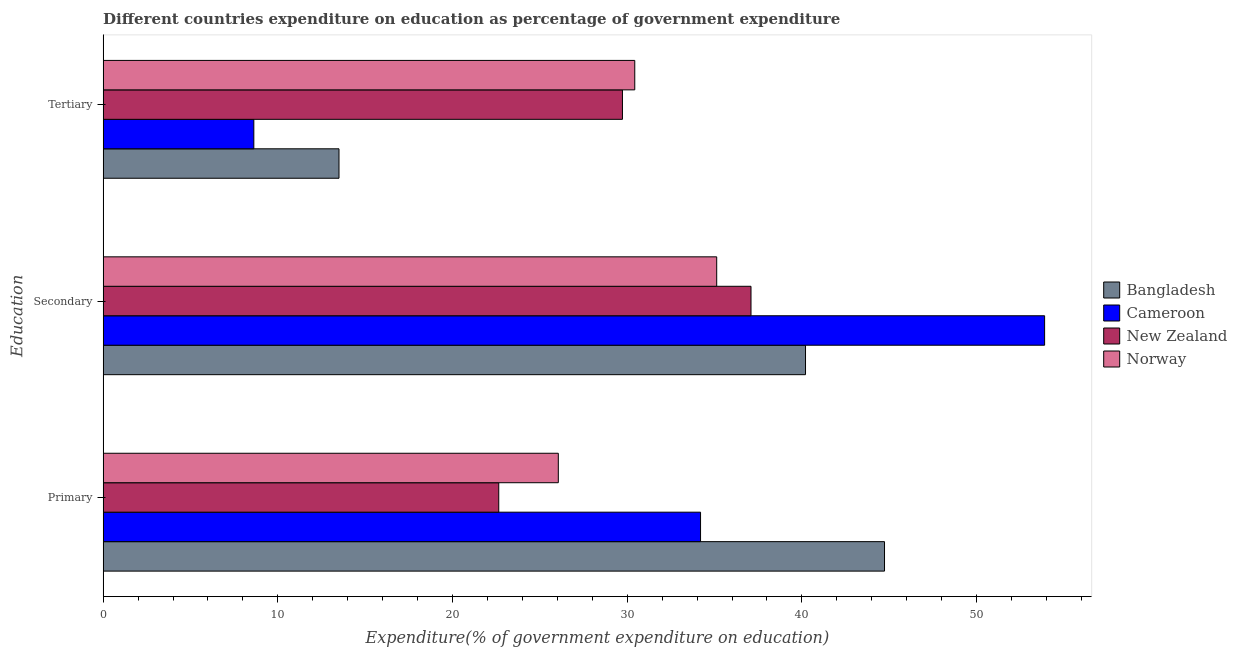How many different coloured bars are there?
Offer a very short reply. 4. How many groups of bars are there?
Your response must be concise. 3. Are the number of bars per tick equal to the number of legend labels?
Make the answer very short. Yes. Are the number of bars on each tick of the Y-axis equal?
Your answer should be compact. Yes. What is the label of the 1st group of bars from the top?
Keep it short and to the point. Tertiary. What is the expenditure on primary education in Norway?
Provide a succinct answer. 26.06. Across all countries, what is the maximum expenditure on tertiary education?
Your response must be concise. 30.43. Across all countries, what is the minimum expenditure on secondary education?
Offer a very short reply. 35.12. In which country was the expenditure on tertiary education maximum?
Keep it short and to the point. Norway. In which country was the expenditure on tertiary education minimum?
Keep it short and to the point. Cameroon. What is the total expenditure on secondary education in the graph?
Give a very brief answer. 166.31. What is the difference between the expenditure on secondary education in Norway and that in Bangladesh?
Provide a short and direct response. -5.08. What is the difference between the expenditure on primary education in New Zealand and the expenditure on tertiary education in Cameroon?
Offer a terse response. 14.02. What is the average expenditure on primary education per country?
Your response must be concise. 31.91. What is the difference between the expenditure on secondary education and expenditure on primary education in New Zealand?
Offer a terse response. 14.44. In how many countries, is the expenditure on secondary education greater than 22 %?
Provide a succinct answer. 4. What is the ratio of the expenditure on primary education in Norway to that in Cameroon?
Provide a succinct answer. 0.76. What is the difference between the highest and the second highest expenditure on tertiary education?
Give a very brief answer. 0.7. What is the difference between the highest and the lowest expenditure on primary education?
Offer a terse response. 22.08. What does the 3rd bar from the top in Primary represents?
Give a very brief answer. Cameroon. Is it the case that in every country, the sum of the expenditure on primary education and expenditure on secondary education is greater than the expenditure on tertiary education?
Offer a terse response. Yes. How many countries are there in the graph?
Keep it short and to the point. 4. Does the graph contain any zero values?
Offer a very short reply. No. Does the graph contain grids?
Your answer should be very brief. No. How many legend labels are there?
Offer a terse response. 4. How are the legend labels stacked?
Provide a succinct answer. Vertical. What is the title of the graph?
Keep it short and to the point. Different countries expenditure on education as percentage of government expenditure. Does "Swaziland" appear as one of the legend labels in the graph?
Your answer should be very brief. No. What is the label or title of the X-axis?
Make the answer very short. Expenditure(% of government expenditure on education). What is the label or title of the Y-axis?
Provide a short and direct response. Education. What is the Expenditure(% of government expenditure on education) of Bangladesh in Primary?
Ensure brevity in your answer.  44.73. What is the Expenditure(% of government expenditure on education) of Cameroon in Primary?
Give a very brief answer. 34.2. What is the Expenditure(% of government expenditure on education) of New Zealand in Primary?
Ensure brevity in your answer.  22.65. What is the Expenditure(% of government expenditure on education) of Norway in Primary?
Offer a terse response. 26.06. What is the Expenditure(% of government expenditure on education) in Bangladesh in Secondary?
Make the answer very short. 40.21. What is the Expenditure(% of government expenditure on education) of Cameroon in Secondary?
Make the answer very short. 53.89. What is the Expenditure(% of government expenditure on education) in New Zealand in Secondary?
Provide a short and direct response. 37.09. What is the Expenditure(% of government expenditure on education) in Norway in Secondary?
Your answer should be very brief. 35.12. What is the Expenditure(% of government expenditure on education) in Bangladesh in Tertiary?
Offer a very short reply. 13.5. What is the Expenditure(% of government expenditure on education) of Cameroon in Tertiary?
Keep it short and to the point. 8.63. What is the Expenditure(% of government expenditure on education) of New Zealand in Tertiary?
Make the answer very short. 29.73. What is the Expenditure(% of government expenditure on education) in Norway in Tertiary?
Provide a short and direct response. 30.43. Across all Education, what is the maximum Expenditure(% of government expenditure on education) in Bangladesh?
Keep it short and to the point. 44.73. Across all Education, what is the maximum Expenditure(% of government expenditure on education) of Cameroon?
Your answer should be very brief. 53.89. Across all Education, what is the maximum Expenditure(% of government expenditure on education) of New Zealand?
Your answer should be very brief. 37.09. Across all Education, what is the maximum Expenditure(% of government expenditure on education) of Norway?
Your answer should be very brief. 35.12. Across all Education, what is the minimum Expenditure(% of government expenditure on education) of Bangladesh?
Provide a succinct answer. 13.5. Across all Education, what is the minimum Expenditure(% of government expenditure on education) of Cameroon?
Provide a succinct answer. 8.63. Across all Education, what is the minimum Expenditure(% of government expenditure on education) of New Zealand?
Offer a very short reply. 22.65. Across all Education, what is the minimum Expenditure(% of government expenditure on education) of Norway?
Provide a succinct answer. 26.06. What is the total Expenditure(% of government expenditure on education) in Bangladesh in the graph?
Ensure brevity in your answer.  98.44. What is the total Expenditure(% of government expenditure on education) of Cameroon in the graph?
Ensure brevity in your answer.  96.71. What is the total Expenditure(% of government expenditure on education) of New Zealand in the graph?
Your answer should be compact. 89.46. What is the total Expenditure(% of government expenditure on education) in Norway in the graph?
Make the answer very short. 91.61. What is the difference between the Expenditure(% of government expenditure on education) in Bangladesh in Primary and that in Secondary?
Keep it short and to the point. 4.52. What is the difference between the Expenditure(% of government expenditure on education) of Cameroon in Primary and that in Secondary?
Offer a very short reply. -19.7. What is the difference between the Expenditure(% of government expenditure on education) in New Zealand in Primary and that in Secondary?
Your answer should be compact. -14.44. What is the difference between the Expenditure(% of government expenditure on education) of Norway in Primary and that in Secondary?
Provide a short and direct response. -9.07. What is the difference between the Expenditure(% of government expenditure on education) in Bangladesh in Primary and that in Tertiary?
Provide a short and direct response. 31.23. What is the difference between the Expenditure(% of government expenditure on education) of Cameroon in Primary and that in Tertiary?
Make the answer very short. 25.57. What is the difference between the Expenditure(% of government expenditure on education) of New Zealand in Primary and that in Tertiary?
Your response must be concise. -7.08. What is the difference between the Expenditure(% of government expenditure on education) of Norway in Primary and that in Tertiary?
Offer a very short reply. -4.38. What is the difference between the Expenditure(% of government expenditure on education) in Bangladesh in Secondary and that in Tertiary?
Offer a very short reply. 26.7. What is the difference between the Expenditure(% of government expenditure on education) in Cameroon in Secondary and that in Tertiary?
Make the answer very short. 45.27. What is the difference between the Expenditure(% of government expenditure on education) of New Zealand in Secondary and that in Tertiary?
Offer a very short reply. 7.36. What is the difference between the Expenditure(% of government expenditure on education) in Norway in Secondary and that in Tertiary?
Your answer should be very brief. 4.69. What is the difference between the Expenditure(% of government expenditure on education) of Bangladesh in Primary and the Expenditure(% of government expenditure on education) of Cameroon in Secondary?
Ensure brevity in your answer.  -9.16. What is the difference between the Expenditure(% of government expenditure on education) of Bangladesh in Primary and the Expenditure(% of government expenditure on education) of New Zealand in Secondary?
Give a very brief answer. 7.64. What is the difference between the Expenditure(% of government expenditure on education) in Bangladesh in Primary and the Expenditure(% of government expenditure on education) in Norway in Secondary?
Your answer should be very brief. 9.61. What is the difference between the Expenditure(% of government expenditure on education) in Cameroon in Primary and the Expenditure(% of government expenditure on education) in New Zealand in Secondary?
Make the answer very short. -2.89. What is the difference between the Expenditure(% of government expenditure on education) in Cameroon in Primary and the Expenditure(% of government expenditure on education) in Norway in Secondary?
Make the answer very short. -0.93. What is the difference between the Expenditure(% of government expenditure on education) in New Zealand in Primary and the Expenditure(% of government expenditure on education) in Norway in Secondary?
Offer a very short reply. -12.48. What is the difference between the Expenditure(% of government expenditure on education) in Bangladesh in Primary and the Expenditure(% of government expenditure on education) in Cameroon in Tertiary?
Your answer should be compact. 36.1. What is the difference between the Expenditure(% of government expenditure on education) in Bangladesh in Primary and the Expenditure(% of government expenditure on education) in New Zealand in Tertiary?
Offer a terse response. 15. What is the difference between the Expenditure(% of government expenditure on education) in Bangladesh in Primary and the Expenditure(% of government expenditure on education) in Norway in Tertiary?
Your response must be concise. 14.3. What is the difference between the Expenditure(% of government expenditure on education) in Cameroon in Primary and the Expenditure(% of government expenditure on education) in New Zealand in Tertiary?
Provide a succinct answer. 4.47. What is the difference between the Expenditure(% of government expenditure on education) in Cameroon in Primary and the Expenditure(% of government expenditure on education) in Norway in Tertiary?
Keep it short and to the point. 3.77. What is the difference between the Expenditure(% of government expenditure on education) of New Zealand in Primary and the Expenditure(% of government expenditure on education) of Norway in Tertiary?
Keep it short and to the point. -7.79. What is the difference between the Expenditure(% of government expenditure on education) in Bangladesh in Secondary and the Expenditure(% of government expenditure on education) in Cameroon in Tertiary?
Your response must be concise. 31.58. What is the difference between the Expenditure(% of government expenditure on education) in Bangladesh in Secondary and the Expenditure(% of government expenditure on education) in New Zealand in Tertiary?
Offer a very short reply. 10.48. What is the difference between the Expenditure(% of government expenditure on education) of Bangladesh in Secondary and the Expenditure(% of government expenditure on education) of Norway in Tertiary?
Your answer should be compact. 9.77. What is the difference between the Expenditure(% of government expenditure on education) in Cameroon in Secondary and the Expenditure(% of government expenditure on education) in New Zealand in Tertiary?
Make the answer very short. 24.16. What is the difference between the Expenditure(% of government expenditure on education) of Cameroon in Secondary and the Expenditure(% of government expenditure on education) of Norway in Tertiary?
Offer a very short reply. 23.46. What is the difference between the Expenditure(% of government expenditure on education) in New Zealand in Secondary and the Expenditure(% of government expenditure on education) in Norway in Tertiary?
Your answer should be very brief. 6.65. What is the average Expenditure(% of government expenditure on education) in Bangladesh per Education?
Offer a terse response. 32.81. What is the average Expenditure(% of government expenditure on education) of Cameroon per Education?
Ensure brevity in your answer.  32.24. What is the average Expenditure(% of government expenditure on education) in New Zealand per Education?
Ensure brevity in your answer.  29.82. What is the average Expenditure(% of government expenditure on education) in Norway per Education?
Provide a succinct answer. 30.54. What is the difference between the Expenditure(% of government expenditure on education) in Bangladesh and Expenditure(% of government expenditure on education) in Cameroon in Primary?
Provide a short and direct response. 10.53. What is the difference between the Expenditure(% of government expenditure on education) of Bangladesh and Expenditure(% of government expenditure on education) of New Zealand in Primary?
Give a very brief answer. 22.08. What is the difference between the Expenditure(% of government expenditure on education) in Bangladesh and Expenditure(% of government expenditure on education) in Norway in Primary?
Provide a succinct answer. 18.67. What is the difference between the Expenditure(% of government expenditure on education) in Cameroon and Expenditure(% of government expenditure on education) in New Zealand in Primary?
Provide a short and direct response. 11.55. What is the difference between the Expenditure(% of government expenditure on education) of Cameroon and Expenditure(% of government expenditure on education) of Norway in Primary?
Your answer should be very brief. 8.14. What is the difference between the Expenditure(% of government expenditure on education) of New Zealand and Expenditure(% of government expenditure on education) of Norway in Primary?
Keep it short and to the point. -3.41. What is the difference between the Expenditure(% of government expenditure on education) in Bangladesh and Expenditure(% of government expenditure on education) in Cameroon in Secondary?
Make the answer very short. -13.69. What is the difference between the Expenditure(% of government expenditure on education) in Bangladesh and Expenditure(% of government expenditure on education) in New Zealand in Secondary?
Ensure brevity in your answer.  3.12. What is the difference between the Expenditure(% of government expenditure on education) in Bangladesh and Expenditure(% of government expenditure on education) in Norway in Secondary?
Your response must be concise. 5.08. What is the difference between the Expenditure(% of government expenditure on education) of Cameroon and Expenditure(% of government expenditure on education) of New Zealand in Secondary?
Provide a short and direct response. 16.81. What is the difference between the Expenditure(% of government expenditure on education) in Cameroon and Expenditure(% of government expenditure on education) in Norway in Secondary?
Offer a terse response. 18.77. What is the difference between the Expenditure(% of government expenditure on education) of New Zealand and Expenditure(% of government expenditure on education) of Norway in Secondary?
Offer a terse response. 1.96. What is the difference between the Expenditure(% of government expenditure on education) in Bangladesh and Expenditure(% of government expenditure on education) in Cameroon in Tertiary?
Keep it short and to the point. 4.88. What is the difference between the Expenditure(% of government expenditure on education) in Bangladesh and Expenditure(% of government expenditure on education) in New Zealand in Tertiary?
Give a very brief answer. -16.23. What is the difference between the Expenditure(% of government expenditure on education) in Bangladesh and Expenditure(% of government expenditure on education) in Norway in Tertiary?
Provide a short and direct response. -16.93. What is the difference between the Expenditure(% of government expenditure on education) in Cameroon and Expenditure(% of government expenditure on education) in New Zealand in Tertiary?
Your answer should be compact. -21.1. What is the difference between the Expenditure(% of government expenditure on education) in Cameroon and Expenditure(% of government expenditure on education) in Norway in Tertiary?
Offer a very short reply. -21.81. What is the difference between the Expenditure(% of government expenditure on education) of New Zealand and Expenditure(% of government expenditure on education) of Norway in Tertiary?
Offer a terse response. -0.7. What is the ratio of the Expenditure(% of government expenditure on education) of Bangladesh in Primary to that in Secondary?
Give a very brief answer. 1.11. What is the ratio of the Expenditure(% of government expenditure on education) of Cameroon in Primary to that in Secondary?
Your answer should be very brief. 0.63. What is the ratio of the Expenditure(% of government expenditure on education) in New Zealand in Primary to that in Secondary?
Offer a very short reply. 0.61. What is the ratio of the Expenditure(% of government expenditure on education) of Norway in Primary to that in Secondary?
Make the answer very short. 0.74. What is the ratio of the Expenditure(% of government expenditure on education) of Bangladesh in Primary to that in Tertiary?
Give a very brief answer. 3.31. What is the ratio of the Expenditure(% of government expenditure on education) in Cameroon in Primary to that in Tertiary?
Your answer should be very brief. 3.96. What is the ratio of the Expenditure(% of government expenditure on education) of New Zealand in Primary to that in Tertiary?
Offer a terse response. 0.76. What is the ratio of the Expenditure(% of government expenditure on education) in Norway in Primary to that in Tertiary?
Provide a short and direct response. 0.86. What is the ratio of the Expenditure(% of government expenditure on education) of Bangladesh in Secondary to that in Tertiary?
Ensure brevity in your answer.  2.98. What is the ratio of the Expenditure(% of government expenditure on education) in Cameroon in Secondary to that in Tertiary?
Ensure brevity in your answer.  6.25. What is the ratio of the Expenditure(% of government expenditure on education) in New Zealand in Secondary to that in Tertiary?
Ensure brevity in your answer.  1.25. What is the ratio of the Expenditure(% of government expenditure on education) of Norway in Secondary to that in Tertiary?
Your answer should be very brief. 1.15. What is the difference between the highest and the second highest Expenditure(% of government expenditure on education) of Bangladesh?
Keep it short and to the point. 4.52. What is the difference between the highest and the second highest Expenditure(% of government expenditure on education) of Cameroon?
Your answer should be compact. 19.7. What is the difference between the highest and the second highest Expenditure(% of government expenditure on education) in New Zealand?
Your response must be concise. 7.36. What is the difference between the highest and the second highest Expenditure(% of government expenditure on education) of Norway?
Keep it short and to the point. 4.69. What is the difference between the highest and the lowest Expenditure(% of government expenditure on education) of Bangladesh?
Ensure brevity in your answer.  31.23. What is the difference between the highest and the lowest Expenditure(% of government expenditure on education) of Cameroon?
Ensure brevity in your answer.  45.27. What is the difference between the highest and the lowest Expenditure(% of government expenditure on education) in New Zealand?
Keep it short and to the point. 14.44. What is the difference between the highest and the lowest Expenditure(% of government expenditure on education) of Norway?
Keep it short and to the point. 9.07. 